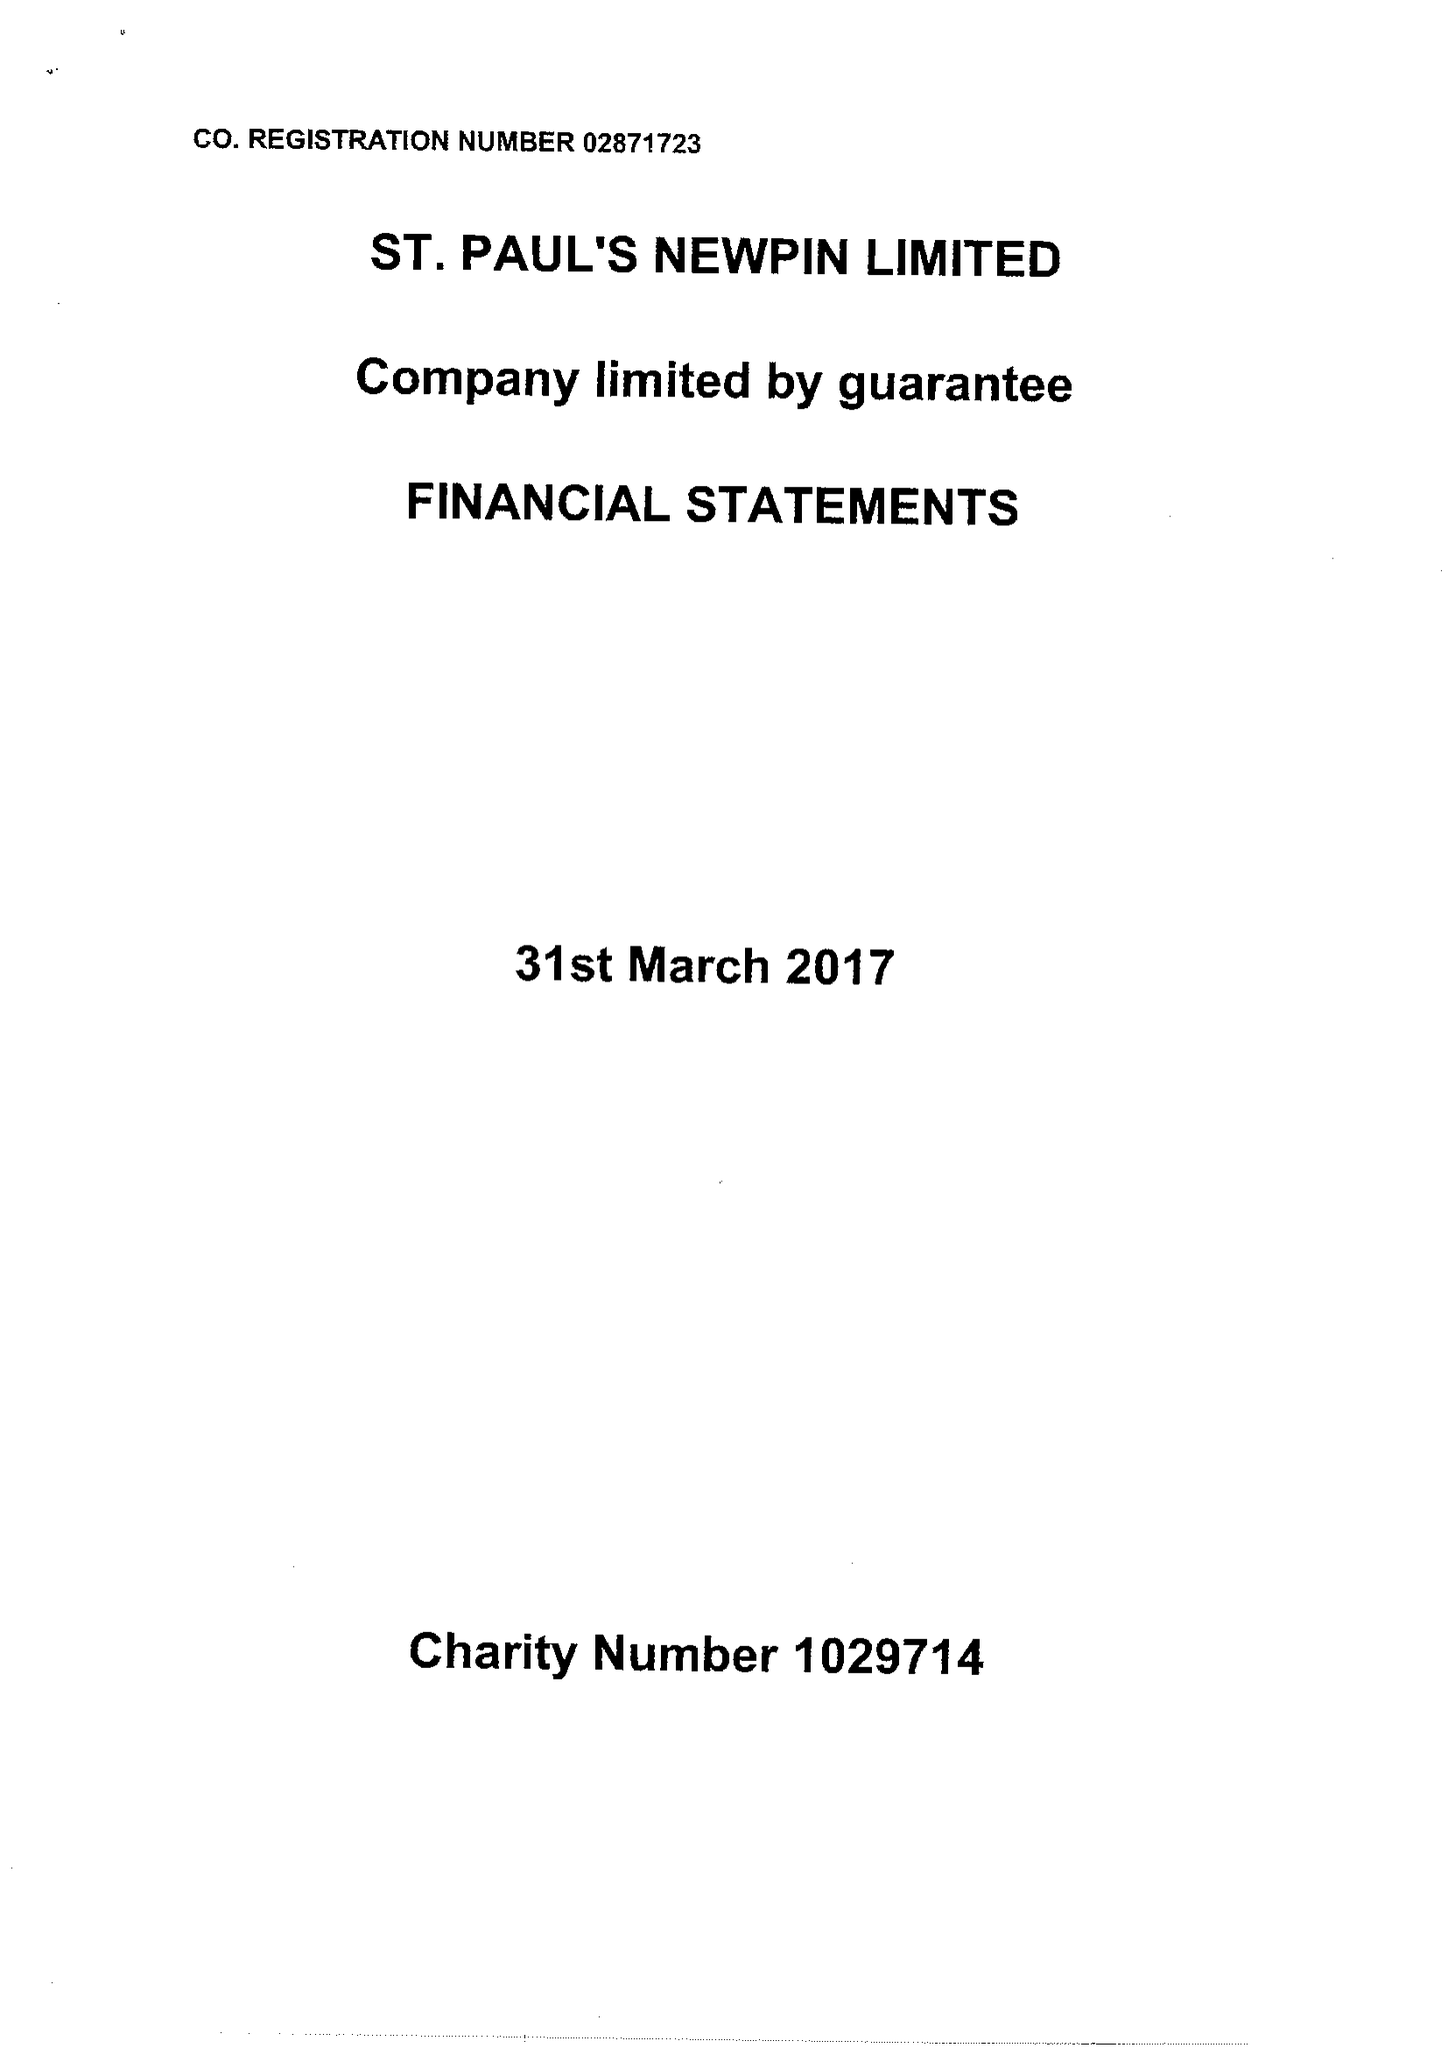What is the value for the address__street_line?
Answer the question using a single word or phrase. GATEFORTH STREET 